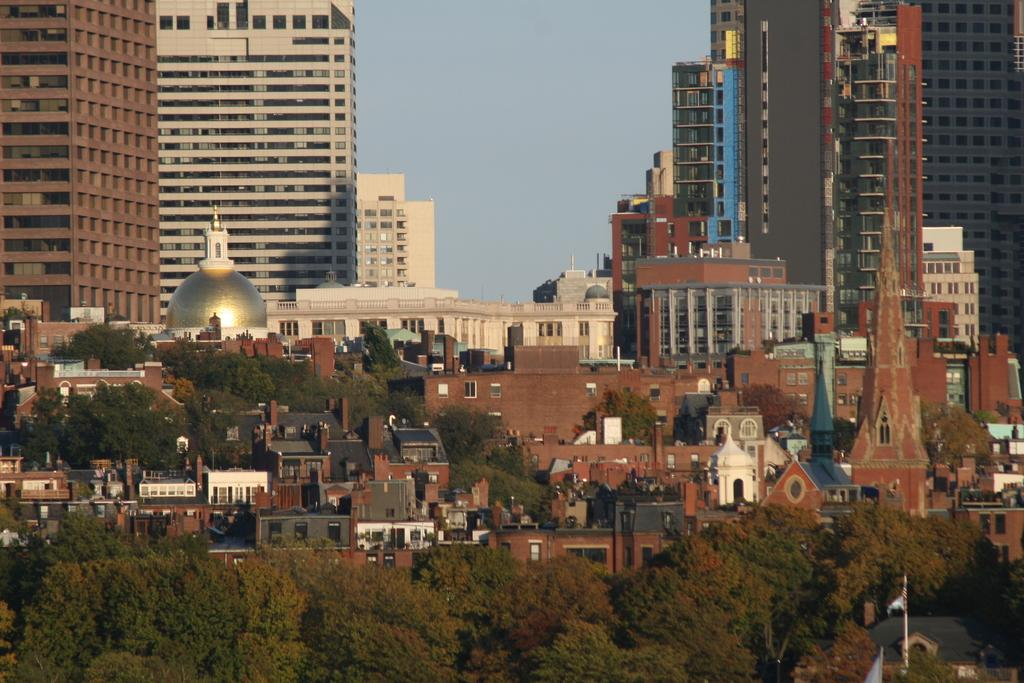What type of vegetation is at the bottom of the image? There are green trees at the bottom of the image. What type of structures are in the middle of the image? There are big buildings in the middle of the image. Can you see a gun being used in the image? There is no gun present in the image. What country is depicted in the image? The image does not depict a specific country; it only shows green trees and big buildings. 